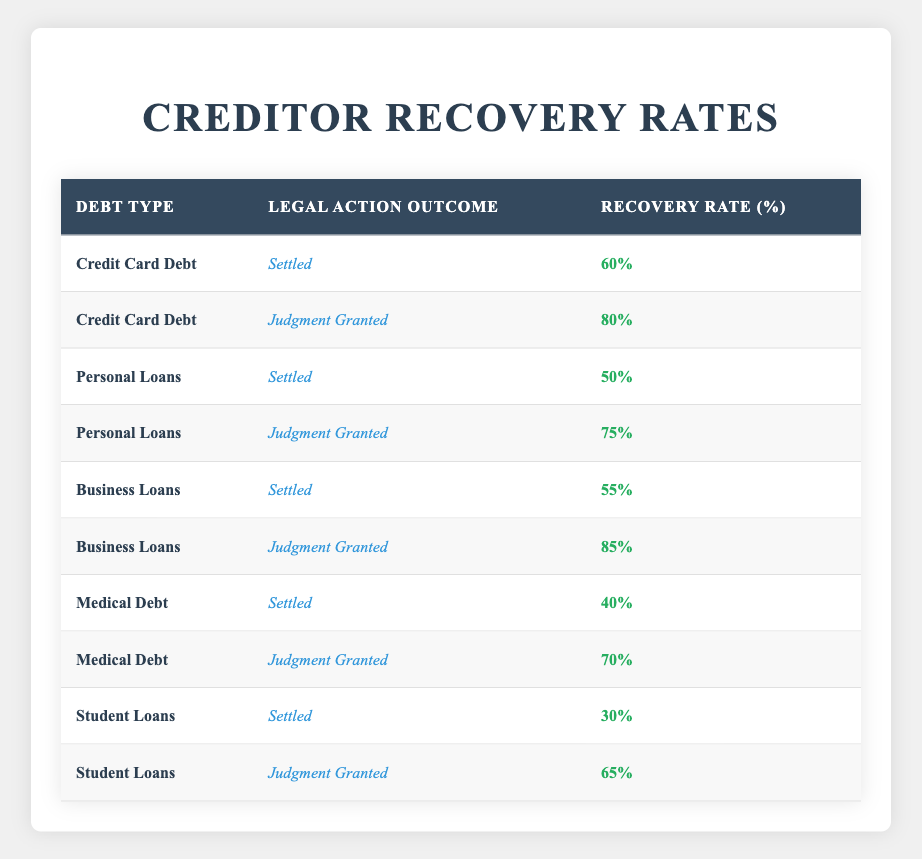What is the recovery rate for Credit Card Debt when the legal action outcome is Settled? The table indicates that for Credit Card Debt under the legal action outcome of Settled, the recovery rate is explicitly listed as 60%.
Answer: 60% What is the recovery rate for Personal Loans when the legal action outcome is Judgment Granted? Referring to the table, the recovery rate for Personal Loans with a legal action outcome of Judgment Granted is given as 75%.
Answer: 75% Which type of debt has the lowest recovery rate when settled? By examining the Settled outcomes in the table, we see the recovery rates: Credit Card Debt (60%), Personal Loans (50%), Business Loans (55%), Medical Debt (40%), and Student Loans (30%). The lowest of these is for Student Loans at 30%.
Answer: Student Loans What is the average recovery rate for Business Loans? The recovery rates for Business Loans are 55% (Settled) and 85% (Judgment Granted). To find the average, we sum these values: 55 + 85 = 140, and divide by the number of outcomes (2), resulting in an average of 140/2 = 70%.
Answer: 70% Is the recovery rate for Medical Debt greater when there is a Judgment Granted versus when it is Settled? Analyzing the table: Medical Debt has a recovery rate of 70% when Judgment is Granted and 40% when Settled. Since 70% is greater than 40%, we confirm that the statement is true.
Answer: Yes Which type of debt has the highest recovery rate in the event of a Judgment Granted? Reviewing the Judgment Granted outcomes: Credit Card Debt (80%), Personal Loans (75%), Business Loans (85%), Medical Debt (70%), and Student Loans (65%). The highest recovery rate in this category is from Business Loans at 85%.
Answer: Business Loans What is the difference in recovery rates between Settled and Judgment Granted for Student Loans? From the table, the recovery rate for Student Loans when Settled is 30% and when Judgment is Granted is 65%. To find the difference, we calculate 65 - 30 = 35%.
Answer: 35% Is the recovery rate for Credit Card Debt higher than for Medical Debt in both outcomes? Checking the table: For Credit Card Debt, the rates are 60% (Settled) and 80% (Judgment Granted). For Medical Debt, the rates are 40% (Settled) and 70% (Judgment Granted). Since both Credit Card Debt rates (60% and 80%) are higher than those of Medical Debt (40% and 70%), we confirm the statement is true.
Answer: Yes What is the combined recovery rate for all types of debts when the legal action outcome is Settled? Summarizing the recovery rates for the Settled outcomes: Credit Card Debt (60%), Personal Loans (50%), Business Loans (55%), Medical Debt (40%), and Student Loans (30%). The combined total is 60 + 50 + 55 + 40 + 30 = 235%. Since there are 5 outcomes, the average is 235/5 = 47%.
Answer: 47% 